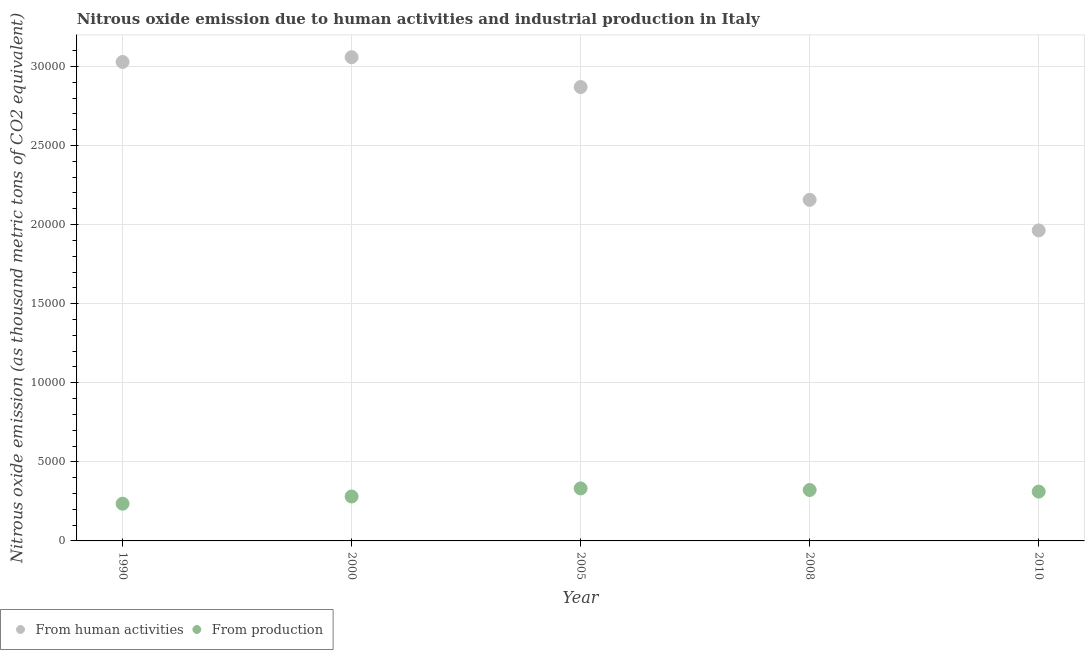How many different coloured dotlines are there?
Your answer should be compact. 2. Is the number of dotlines equal to the number of legend labels?
Provide a succinct answer. Yes. What is the amount of emissions generated from industries in 2010?
Provide a short and direct response. 3117.9. Across all years, what is the maximum amount of emissions from human activities?
Your answer should be very brief. 3.06e+04. Across all years, what is the minimum amount of emissions from human activities?
Provide a succinct answer. 1.96e+04. In which year was the amount of emissions generated from industries minimum?
Your response must be concise. 1990. What is the total amount of emissions from human activities in the graph?
Keep it short and to the point. 1.31e+05. What is the difference between the amount of emissions generated from industries in 1990 and that in 2010?
Ensure brevity in your answer.  -765.2. What is the difference between the amount of emissions generated from industries in 1990 and the amount of emissions from human activities in 2008?
Keep it short and to the point. -1.92e+04. What is the average amount of emissions from human activities per year?
Your answer should be very brief. 2.62e+04. In the year 1990, what is the difference between the amount of emissions generated from industries and amount of emissions from human activities?
Provide a short and direct response. -2.79e+04. In how many years, is the amount of emissions from human activities greater than 28000 thousand metric tons?
Make the answer very short. 3. What is the ratio of the amount of emissions generated from industries in 2000 to that in 2008?
Your response must be concise. 0.87. Is the difference between the amount of emissions generated from industries in 2000 and 2008 greater than the difference between the amount of emissions from human activities in 2000 and 2008?
Give a very brief answer. No. What is the difference between the highest and the second highest amount of emissions generated from industries?
Your response must be concise. 100.4. What is the difference between the highest and the lowest amount of emissions generated from industries?
Provide a short and direct response. 967.6. In how many years, is the amount of emissions generated from industries greater than the average amount of emissions generated from industries taken over all years?
Provide a succinct answer. 3. Is the sum of the amount of emissions from human activities in 2000 and 2008 greater than the maximum amount of emissions generated from industries across all years?
Give a very brief answer. Yes. Does the amount of emissions from human activities monotonically increase over the years?
Your answer should be compact. No. Is the amount of emissions generated from industries strictly less than the amount of emissions from human activities over the years?
Offer a terse response. Yes. What is the difference between two consecutive major ticks on the Y-axis?
Your response must be concise. 5000. Does the graph contain any zero values?
Offer a terse response. No. Where does the legend appear in the graph?
Ensure brevity in your answer.  Bottom left. How are the legend labels stacked?
Your answer should be compact. Horizontal. What is the title of the graph?
Your response must be concise. Nitrous oxide emission due to human activities and industrial production in Italy. What is the label or title of the Y-axis?
Your response must be concise. Nitrous oxide emission (as thousand metric tons of CO2 equivalent). What is the Nitrous oxide emission (as thousand metric tons of CO2 equivalent) in From human activities in 1990?
Keep it short and to the point. 3.03e+04. What is the Nitrous oxide emission (as thousand metric tons of CO2 equivalent) of From production in 1990?
Make the answer very short. 2352.7. What is the Nitrous oxide emission (as thousand metric tons of CO2 equivalent) in From human activities in 2000?
Your answer should be compact. 3.06e+04. What is the Nitrous oxide emission (as thousand metric tons of CO2 equivalent) in From production in 2000?
Offer a terse response. 2808.4. What is the Nitrous oxide emission (as thousand metric tons of CO2 equivalent) in From human activities in 2005?
Provide a short and direct response. 2.87e+04. What is the Nitrous oxide emission (as thousand metric tons of CO2 equivalent) of From production in 2005?
Your answer should be compact. 3320.3. What is the Nitrous oxide emission (as thousand metric tons of CO2 equivalent) of From human activities in 2008?
Your answer should be compact. 2.16e+04. What is the Nitrous oxide emission (as thousand metric tons of CO2 equivalent) of From production in 2008?
Provide a succinct answer. 3219.9. What is the Nitrous oxide emission (as thousand metric tons of CO2 equivalent) in From human activities in 2010?
Make the answer very short. 1.96e+04. What is the Nitrous oxide emission (as thousand metric tons of CO2 equivalent) of From production in 2010?
Your response must be concise. 3117.9. Across all years, what is the maximum Nitrous oxide emission (as thousand metric tons of CO2 equivalent) in From human activities?
Your response must be concise. 3.06e+04. Across all years, what is the maximum Nitrous oxide emission (as thousand metric tons of CO2 equivalent) of From production?
Your answer should be very brief. 3320.3. Across all years, what is the minimum Nitrous oxide emission (as thousand metric tons of CO2 equivalent) of From human activities?
Your response must be concise. 1.96e+04. Across all years, what is the minimum Nitrous oxide emission (as thousand metric tons of CO2 equivalent) of From production?
Give a very brief answer. 2352.7. What is the total Nitrous oxide emission (as thousand metric tons of CO2 equivalent) in From human activities in the graph?
Make the answer very short. 1.31e+05. What is the total Nitrous oxide emission (as thousand metric tons of CO2 equivalent) of From production in the graph?
Offer a terse response. 1.48e+04. What is the difference between the Nitrous oxide emission (as thousand metric tons of CO2 equivalent) in From human activities in 1990 and that in 2000?
Your response must be concise. -301.2. What is the difference between the Nitrous oxide emission (as thousand metric tons of CO2 equivalent) of From production in 1990 and that in 2000?
Provide a succinct answer. -455.7. What is the difference between the Nitrous oxide emission (as thousand metric tons of CO2 equivalent) in From human activities in 1990 and that in 2005?
Ensure brevity in your answer.  1584.9. What is the difference between the Nitrous oxide emission (as thousand metric tons of CO2 equivalent) in From production in 1990 and that in 2005?
Your answer should be compact. -967.6. What is the difference between the Nitrous oxide emission (as thousand metric tons of CO2 equivalent) of From human activities in 1990 and that in 2008?
Ensure brevity in your answer.  8717. What is the difference between the Nitrous oxide emission (as thousand metric tons of CO2 equivalent) in From production in 1990 and that in 2008?
Keep it short and to the point. -867.2. What is the difference between the Nitrous oxide emission (as thousand metric tons of CO2 equivalent) in From human activities in 1990 and that in 2010?
Make the answer very short. 1.07e+04. What is the difference between the Nitrous oxide emission (as thousand metric tons of CO2 equivalent) of From production in 1990 and that in 2010?
Provide a short and direct response. -765.2. What is the difference between the Nitrous oxide emission (as thousand metric tons of CO2 equivalent) in From human activities in 2000 and that in 2005?
Provide a short and direct response. 1886.1. What is the difference between the Nitrous oxide emission (as thousand metric tons of CO2 equivalent) in From production in 2000 and that in 2005?
Make the answer very short. -511.9. What is the difference between the Nitrous oxide emission (as thousand metric tons of CO2 equivalent) in From human activities in 2000 and that in 2008?
Your answer should be compact. 9018.2. What is the difference between the Nitrous oxide emission (as thousand metric tons of CO2 equivalent) of From production in 2000 and that in 2008?
Offer a terse response. -411.5. What is the difference between the Nitrous oxide emission (as thousand metric tons of CO2 equivalent) in From human activities in 2000 and that in 2010?
Give a very brief answer. 1.10e+04. What is the difference between the Nitrous oxide emission (as thousand metric tons of CO2 equivalent) of From production in 2000 and that in 2010?
Your answer should be very brief. -309.5. What is the difference between the Nitrous oxide emission (as thousand metric tons of CO2 equivalent) of From human activities in 2005 and that in 2008?
Make the answer very short. 7132.1. What is the difference between the Nitrous oxide emission (as thousand metric tons of CO2 equivalent) in From production in 2005 and that in 2008?
Your answer should be very brief. 100.4. What is the difference between the Nitrous oxide emission (as thousand metric tons of CO2 equivalent) of From human activities in 2005 and that in 2010?
Make the answer very short. 9065.9. What is the difference between the Nitrous oxide emission (as thousand metric tons of CO2 equivalent) in From production in 2005 and that in 2010?
Your answer should be very brief. 202.4. What is the difference between the Nitrous oxide emission (as thousand metric tons of CO2 equivalent) in From human activities in 2008 and that in 2010?
Offer a very short reply. 1933.8. What is the difference between the Nitrous oxide emission (as thousand metric tons of CO2 equivalent) of From production in 2008 and that in 2010?
Offer a terse response. 102. What is the difference between the Nitrous oxide emission (as thousand metric tons of CO2 equivalent) in From human activities in 1990 and the Nitrous oxide emission (as thousand metric tons of CO2 equivalent) in From production in 2000?
Offer a terse response. 2.75e+04. What is the difference between the Nitrous oxide emission (as thousand metric tons of CO2 equivalent) of From human activities in 1990 and the Nitrous oxide emission (as thousand metric tons of CO2 equivalent) of From production in 2005?
Keep it short and to the point. 2.70e+04. What is the difference between the Nitrous oxide emission (as thousand metric tons of CO2 equivalent) of From human activities in 1990 and the Nitrous oxide emission (as thousand metric tons of CO2 equivalent) of From production in 2008?
Keep it short and to the point. 2.71e+04. What is the difference between the Nitrous oxide emission (as thousand metric tons of CO2 equivalent) of From human activities in 1990 and the Nitrous oxide emission (as thousand metric tons of CO2 equivalent) of From production in 2010?
Your answer should be very brief. 2.72e+04. What is the difference between the Nitrous oxide emission (as thousand metric tons of CO2 equivalent) in From human activities in 2000 and the Nitrous oxide emission (as thousand metric tons of CO2 equivalent) in From production in 2005?
Ensure brevity in your answer.  2.73e+04. What is the difference between the Nitrous oxide emission (as thousand metric tons of CO2 equivalent) of From human activities in 2000 and the Nitrous oxide emission (as thousand metric tons of CO2 equivalent) of From production in 2008?
Ensure brevity in your answer.  2.74e+04. What is the difference between the Nitrous oxide emission (as thousand metric tons of CO2 equivalent) of From human activities in 2000 and the Nitrous oxide emission (as thousand metric tons of CO2 equivalent) of From production in 2010?
Keep it short and to the point. 2.75e+04. What is the difference between the Nitrous oxide emission (as thousand metric tons of CO2 equivalent) of From human activities in 2005 and the Nitrous oxide emission (as thousand metric tons of CO2 equivalent) of From production in 2008?
Your answer should be very brief. 2.55e+04. What is the difference between the Nitrous oxide emission (as thousand metric tons of CO2 equivalent) in From human activities in 2005 and the Nitrous oxide emission (as thousand metric tons of CO2 equivalent) in From production in 2010?
Your response must be concise. 2.56e+04. What is the difference between the Nitrous oxide emission (as thousand metric tons of CO2 equivalent) of From human activities in 2008 and the Nitrous oxide emission (as thousand metric tons of CO2 equivalent) of From production in 2010?
Provide a succinct answer. 1.84e+04. What is the average Nitrous oxide emission (as thousand metric tons of CO2 equivalent) in From human activities per year?
Your response must be concise. 2.62e+04. What is the average Nitrous oxide emission (as thousand metric tons of CO2 equivalent) of From production per year?
Provide a short and direct response. 2963.84. In the year 1990, what is the difference between the Nitrous oxide emission (as thousand metric tons of CO2 equivalent) in From human activities and Nitrous oxide emission (as thousand metric tons of CO2 equivalent) in From production?
Provide a succinct answer. 2.79e+04. In the year 2000, what is the difference between the Nitrous oxide emission (as thousand metric tons of CO2 equivalent) in From human activities and Nitrous oxide emission (as thousand metric tons of CO2 equivalent) in From production?
Your answer should be compact. 2.78e+04. In the year 2005, what is the difference between the Nitrous oxide emission (as thousand metric tons of CO2 equivalent) of From human activities and Nitrous oxide emission (as thousand metric tons of CO2 equivalent) of From production?
Provide a succinct answer. 2.54e+04. In the year 2008, what is the difference between the Nitrous oxide emission (as thousand metric tons of CO2 equivalent) in From human activities and Nitrous oxide emission (as thousand metric tons of CO2 equivalent) in From production?
Offer a very short reply. 1.83e+04. In the year 2010, what is the difference between the Nitrous oxide emission (as thousand metric tons of CO2 equivalent) in From human activities and Nitrous oxide emission (as thousand metric tons of CO2 equivalent) in From production?
Ensure brevity in your answer.  1.65e+04. What is the ratio of the Nitrous oxide emission (as thousand metric tons of CO2 equivalent) of From human activities in 1990 to that in 2000?
Provide a short and direct response. 0.99. What is the ratio of the Nitrous oxide emission (as thousand metric tons of CO2 equivalent) in From production in 1990 to that in 2000?
Offer a very short reply. 0.84. What is the ratio of the Nitrous oxide emission (as thousand metric tons of CO2 equivalent) in From human activities in 1990 to that in 2005?
Provide a succinct answer. 1.06. What is the ratio of the Nitrous oxide emission (as thousand metric tons of CO2 equivalent) in From production in 1990 to that in 2005?
Your answer should be very brief. 0.71. What is the ratio of the Nitrous oxide emission (as thousand metric tons of CO2 equivalent) in From human activities in 1990 to that in 2008?
Ensure brevity in your answer.  1.4. What is the ratio of the Nitrous oxide emission (as thousand metric tons of CO2 equivalent) of From production in 1990 to that in 2008?
Keep it short and to the point. 0.73. What is the ratio of the Nitrous oxide emission (as thousand metric tons of CO2 equivalent) of From human activities in 1990 to that in 2010?
Your answer should be compact. 1.54. What is the ratio of the Nitrous oxide emission (as thousand metric tons of CO2 equivalent) in From production in 1990 to that in 2010?
Provide a succinct answer. 0.75. What is the ratio of the Nitrous oxide emission (as thousand metric tons of CO2 equivalent) in From human activities in 2000 to that in 2005?
Your answer should be compact. 1.07. What is the ratio of the Nitrous oxide emission (as thousand metric tons of CO2 equivalent) in From production in 2000 to that in 2005?
Offer a terse response. 0.85. What is the ratio of the Nitrous oxide emission (as thousand metric tons of CO2 equivalent) of From human activities in 2000 to that in 2008?
Give a very brief answer. 1.42. What is the ratio of the Nitrous oxide emission (as thousand metric tons of CO2 equivalent) of From production in 2000 to that in 2008?
Make the answer very short. 0.87. What is the ratio of the Nitrous oxide emission (as thousand metric tons of CO2 equivalent) in From human activities in 2000 to that in 2010?
Keep it short and to the point. 1.56. What is the ratio of the Nitrous oxide emission (as thousand metric tons of CO2 equivalent) of From production in 2000 to that in 2010?
Make the answer very short. 0.9. What is the ratio of the Nitrous oxide emission (as thousand metric tons of CO2 equivalent) in From human activities in 2005 to that in 2008?
Make the answer very short. 1.33. What is the ratio of the Nitrous oxide emission (as thousand metric tons of CO2 equivalent) in From production in 2005 to that in 2008?
Your answer should be very brief. 1.03. What is the ratio of the Nitrous oxide emission (as thousand metric tons of CO2 equivalent) of From human activities in 2005 to that in 2010?
Ensure brevity in your answer.  1.46. What is the ratio of the Nitrous oxide emission (as thousand metric tons of CO2 equivalent) in From production in 2005 to that in 2010?
Your response must be concise. 1.06. What is the ratio of the Nitrous oxide emission (as thousand metric tons of CO2 equivalent) of From human activities in 2008 to that in 2010?
Your response must be concise. 1.1. What is the ratio of the Nitrous oxide emission (as thousand metric tons of CO2 equivalent) in From production in 2008 to that in 2010?
Your answer should be very brief. 1.03. What is the difference between the highest and the second highest Nitrous oxide emission (as thousand metric tons of CO2 equivalent) in From human activities?
Provide a succinct answer. 301.2. What is the difference between the highest and the second highest Nitrous oxide emission (as thousand metric tons of CO2 equivalent) in From production?
Provide a short and direct response. 100.4. What is the difference between the highest and the lowest Nitrous oxide emission (as thousand metric tons of CO2 equivalent) of From human activities?
Provide a succinct answer. 1.10e+04. What is the difference between the highest and the lowest Nitrous oxide emission (as thousand metric tons of CO2 equivalent) of From production?
Offer a very short reply. 967.6. 